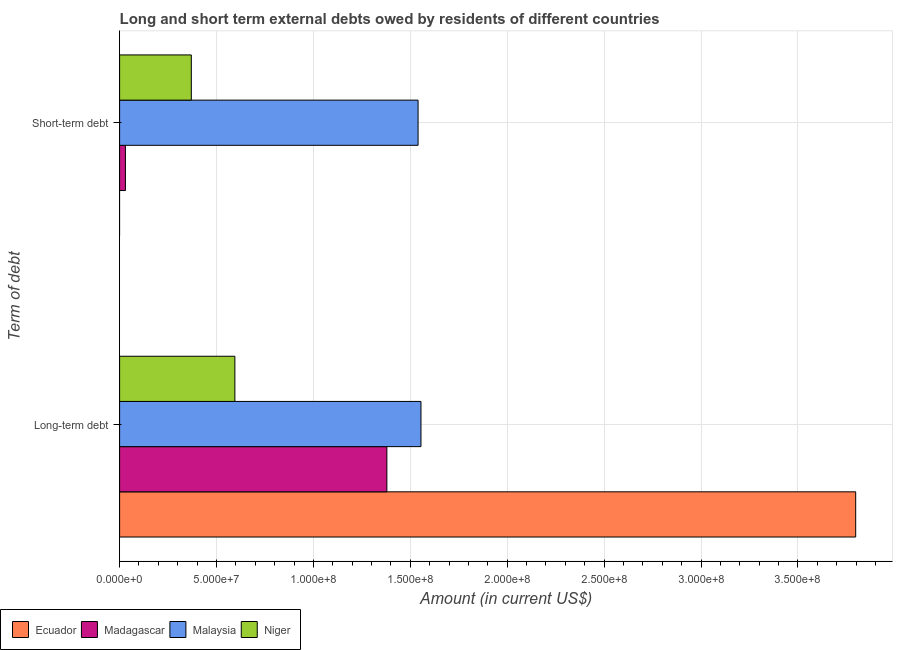How many groups of bars are there?
Your answer should be compact. 2. How many bars are there on the 1st tick from the top?
Your answer should be compact. 3. What is the label of the 2nd group of bars from the top?
Make the answer very short. Long-term debt. What is the short-term debts owed by residents in Ecuador?
Your response must be concise. 0. Across all countries, what is the maximum long-term debts owed by residents?
Provide a succinct answer. 3.80e+08. Across all countries, what is the minimum short-term debts owed by residents?
Your answer should be compact. 0. In which country was the long-term debts owed by residents maximum?
Your response must be concise. Ecuador. What is the total short-term debts owed by residents in the graph?
Your response must be concise. 1.94e+08. What is the difference between the short-term debts owed by residents in Malaysia and that in Niger?
Keep it short and to the point. 1.17e+08. What is the difference between the short-term debts owed by residents in Malaysia and the long-term debts owed by residents in Niger?
Offer a very short reply. 9.45e+07. What is the average short-term debts owed by residents per country?
Your answer should be very brief. 4.85e+07. What is the difference between the long-term debts owed by residents and short-term debts owed by residents in Madagascar?
Your response must be concise. 1.35e+08. What is the ratio of the long-term debts owed by residents in Madagascar to that in Malaysia?
Make the answer very short. 0.89. Are all the bars in the graph horizontal?
Your response must be concise. Yes. How many countries are there in the graph?
Keep it short and to the point. 4. Does the graph contain any zero values?
Your answer should be very brief. Yes. Does the graph contain grids?
Your answer should be compact. Yes. Where does the legend appear in the graph?
Offer a terse response. Bottom left. What is the title of the graph?
Provide a succinct answer. Long and short term external debts owed by residents of different countries. What is the label or title of the Y-axis?
Offer a terse response. Term of debt. What is the Amount (in current US$) of Ecuador in Long-term debt?
Make the answer very short. 3.80e+08. What is the Amount (in current US$) of Madagascar in Long-term debt?
Offer a terse response. 1.38e+08. What is the Amount (in current US$) in Malaysia in Long-term debt?
Keep it short and to the point. 1.55e+08. What is the Amount (in current US$) of Niger in Long-term debt?
Keep it short and to the point. 5.95e+07. What is the Amount (in current US$) of Ecuador in Short-term debt?
Your answer should be very brief. 0. What is the Amount (in current US$) in Malaysia in Short-term debt?
Ensure brevity in your answer.  1.54e+08. What is the Amount (in current US$) of Niger in Short-term debt?
Your response must be concise. 3.70e+07. Across all Term of debt, what is the maximum Amount (in current US$) of Ecuador?
Your answer should be compact. 3.80e+08. Across all Term of debt, what is the maximum Amount (in current US$) of Madagascar?
Make the answer very short. 1.38e+08. Across all Term of debt, what is the maximum Amount (in current US$) in Malaysia?
Your answer should be very brief. 1.55e+08. Across all Term of debt, what is the maximum Amount (in current US$) of Niger?
Keep it short and to the point. 5.95e+07. Across all Term of debt, what is the minimum Amount (in current US$) of Ecuador?
Offer a very short reply. 0. Across all Term of debt, what is the minimum Amount (in current US$) in Malaysia?
Make the answer very short. 1.54e+08. Across all Term of debt, what is the minimum Amount (in current US$) of Niger?
Give a very brief answer. 3.70e+07. What is the total Amount (in current US$) in Ecuador in the graph?
Your answer should be compact. 3.80e+08. What is the total Amount (in current US$) of Madagascar in the graph?
Provide a succinct answer. 1.41e+08. What is the total Amount (in current US$) of Malaysia in the graph?
Ensure brevity in your answer.  3.09e+08. What is the total Amount (in current US$) of Niger in the graph?
Give a very brief answer. 9.65e+07. What is the difference between the Amount (in current US$) of Madagascar in Long-term debt and that in Short-term debt?
Provide a succinct answer. 1.35e+08. What is the difference between the Amount (in current US$) of Malaysia in Long-term debt and that in Short-term debt?
Ensure brevity in your answer.  1.50e+06. What is the difference between the Amount (in current US$) in Niger in Long-term debt and that in Short-term debt?
Provide a short and direct response. 2.25e+07. What is the difference between the Amount (in current US$) of Ecuador in Long-term debt and the Amount (in current US$) of Madagascar in Short-term debt?
Your answer should be very brief. 3.77e+08. What is the difference between the Amount (in current US$) of Ecuador in Long-term debt and the Amount (in current US$) of Malaysia in Short-term debt?
Make the answer very short. 2.26e+08. What is the difference between the Amount (in current US$) in Ecuador in Long-term debt and the Amount (in current US$) in Niger in Short-term debt?
Offer a terse response. 3.43e+08. What is the difference between the Amount (in current US$) in Madagascar in Long-term debt and the Amount (in current US$) in Malaysia in Short-term debt?
Offer a terse response. -1.61e+07. What is the difference between the Amount (in current US$) in Madagascar in Long-term debt and the Amount (in current US$) in Niger in Short-term debt?
Offer a very short reply. 1.01e+08. What is the difference between the Amount (in current US$) in Malaysia in Long-term debt and the Amount (in current US$) in Niger in Short-term debt?
Your answer should be very brief. 1.18e+08. What is the average Amount (in current US$) of Ecuador per Term of debt?
Offer a terse response. 1.90e+08. What is the average Amount (in current US$) in Madagascar per Term of debt?
Offer a terse response. 7.05e+07. What is the average Amount (in current US$) of Malaysia per Term of debt?
Give a very brief answer. 1.55e+08. What is the average Amount (in current US$) in Niger per Term of debt?
Provide a succinct answer. 4.82e+07. What is the difference between the Amount (in current US$) in Ecuador and Amount (in current US$) in Madagascar in Long-term debt?
Offer a very short reply. 2.42e+08. What is the difference between the Amount (in current US$) of Ecuador and Amount (in current US$) of Malaysia in Long-term debt?
Your response must be concise. 2.24e+08. What is the difference between the Amount (in current US$) in Ecuador and Amount (in current US$) in Niger in Long-term debt?
Offer a terse response. 3.20e+08. What is the difference between the Amount (in current US$) of Madagascar and Amount (in current US$) of Malaysia in Long-term debt?
Your answer should be compact. -1.76e+07. What is the difference between the Amount (in current US$) of Madagascar and Amount (in current US$) of Niger in Long-term debt?
Provide a short and direct response. 7.84e+07. What is the difference between the Amount (in current US$) of Malaysia and Amount (in current US$) of Niger in Long-term debt?
Provide a succinct answer. 9.60e+07. What is the difference between the Amount (in current US$) in Madagascar and Amount (in current US$) in Malaysia in Short-term debt?
Keep it short and to the point. -1.51e+08. What is the difference between the Amount (in current US$) of Madagascar and Amount (in current US$) of Niger in Short-term debt?
Your answer should be very brief. -3.40e+07. What is the difference between the Amount (in current US$) in Malaysia and Amount (in current US$) in Niger in Short-term debt?
Provide a succinct answer. 1.17e+08. What is the ratio of the Amount (in current US$) in Madagascar in Long-term debt to that in Short-term debt?
Provide a succinct answer. 45.97. What is the ratio of the Amount (in current US$) in Malaysia in Long-term debt to that in Short-term debt?
Give a very brief answer. 1.01. What is the ratio of the Amount (in current US$) in Niger in Long-term debt to that in Short-term debt?
Make the answer very short. 1.61. What is the difference between the highest and the second highest Amount (in current US$) in Madagascar?
Keep it short and to the point. 1.35e+08. What is the difference between the highest and the second highest Amount (in current US$) in Malaysia?
Provide a succinct answer. 1.50e+06. What is the difference between the highest and the second highest Amount (in current US$) in Niger?
Ensure brevity in your answer.  2.25e+07. What is the difference between the highest and the lowest Amount (in current US$) in Ecuador?
Provide a short and direct response. 3.80e+08. What is the difference between the highest and the lowest Amount (in current US$) of Madagascar?
Your answer should be compact. 1.35e+08. What is the difference between the highest and the lowest Amount (in current US$) of Malaysia?
Keep it short and to the point. 1.50e+06. What is the difference between the highest and the lowest Amount (in current US$) in Niger?
Give a very brief answer. 2.25e+07. 